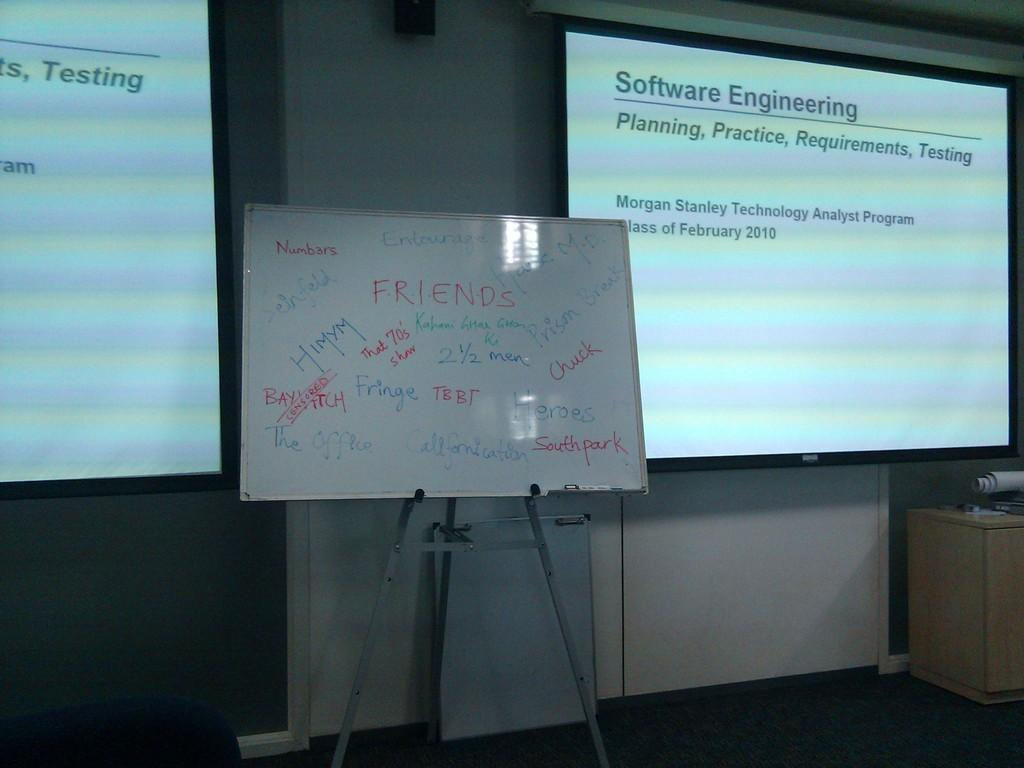<image>
Offer a succinct explanation of the picture presented. A whiteboard with writing on it stands in front of a projected slide titled Software Engineering. 